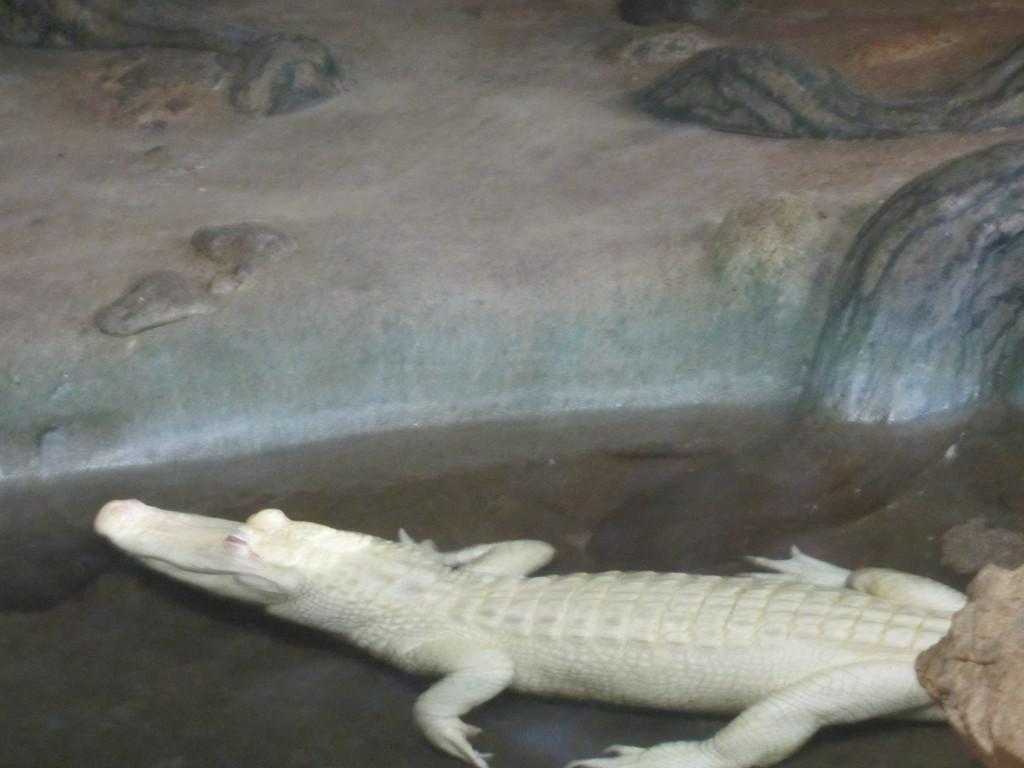What animal is present in the image? There is a crocodile in the image. Where is the crocodile located? The crocodile is in water. What type of park can be seen in the image? There is no park present in the image; it features a crocodile in water. How many members are on the team in the image? There is no team present in the image; it features a crocodile in water. 